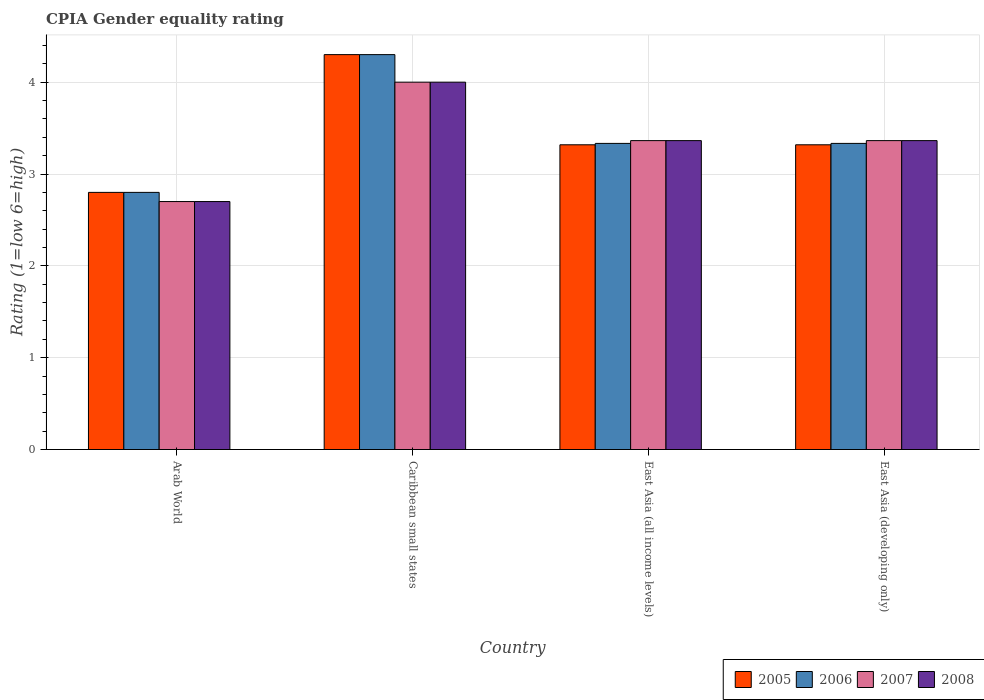How many groups of bars are there?
Offer a terse response. 4. How many bars are there on the 3rd tick from the left?
Your answer should be compact. 4. How many bars are there on the 1st tick from the right?
Your answer should be compact. 4. What is the label of the 1st group of bars from the left?
Provide a succinct answer. Arab World. In how many cases, is the number of bars for a given country not equal to the number of legend labels?
Keep it short and to the point. 0. What is the CPIA rating in 2007 in Caribbean small states?
Keep it short and to the point. 4. Across all countries, what is the minimum CPIA rating in 2007?
Your answer should be compact. 2.7. In which country was the CPIA rating in 2006 maximum?
Your response must be concise. Caribbean small states. In which country was the CPIA rating in 2008 minimum?
Keep it short and to the point. Arab World. What is the total CPIA rating in 2008 in the graph?
Keep it short and to the point. 13.43. What is the difference between the CPIA rating in 2006 in East Asia (all income levels) and the CPIA rating in 2005 in East Asia (developing only)?
Your response must be concise. 0.02. What is the average CPIA rating in 2007 per country?
Your answer should be compact. 3.36. What is the difference between the CPIA rating of/in 2008 and CPIA rating of/in 2007 in East Asia (all income levels)?
Your answer should be compact. 0. What is the ratio of the CPIA rating in 2008 in Caribbean small states to that in East Asia (all income levels)?
Your response must be concise. 1.19. What is the difference between the highest and the second highest CPIA rating in 2008?
Provide a succinct answer. -0.64. What is the difference between the highest and the lowest CPIA rating in 2006?
Give a very brief answer. 1.5. What does the 1st bar from the right in Caribbean small states represents?
Your response must be concise. 2008. Is it the case that in every country, the sum of the CPIA rating in 2006 and CPIA rating in 2005 is greater than the CPIA rating in 2008?
Make the answer very short. Yes. How many bars are there?
Make the answer very short. 16. How many countries are there in the graph?
Provide a short and direct response. 4. What is the difference between two consecutive major ticks on the Y-axis?
Provide a short and direct response. 1. Are the values on the major ticks of Y-axis written in scientific E-notation?
Your response must be concise. No. Does the graph contain any zero values?
Offer a terse response. No. What is the title of the graph?
Offer a terse response. CPIA Gender equality rating. What is the label or title of the X-axis?
Ensure brevity in your answer.  Country. What is the label or title of the Y-axis?
Keep it short and to the point. Rating (1=low 6=high). What is the Rating (1=low 6=high) in 2006 in Caribbean small states?
Offer a very short reply. 4.3. What is the Rating (1=low 6=high) in 2007 in Caribbean small states?
Provide a short and direct response. 4. What is the Rating (1=low 6=high) in 2008 in Caribbean small states?
Keep it short and to the point. 4. What is the Rating (1=low 6=high) of 2005 in East Asia (all income levels)?
Offer a terse response. 3.32. What is the Rating (1=low 6=high) of 2006 in East Asia (all income levels)?
Provide a succinct answer. 3.33. What is the Rating (1=low 6=high) in 2007 in East Asia (all income levels)?
Give a very brief answer. 3.36. What is the Rating (1=low 6=high) in 2008 in East Asia (all income levels)?
Your answer should be very brief. 3.36. What is the Rating (1=low 6=high) of 2005 in East Asia (developing only)?
Your answer should be very brief. 3.32. What is the Rating (1=low 6=high) of 2006 in East Asia (developing only)?
Provide a short and direct response. 3.33. What is the Rating (1=low 6=high) of 2007 in East Asia (developing only)?
Give a very brief answer. 3.36. What is the Rating (1=low 6=high) of 2008 in East Asia (developing only)?
Your answer should be compact. 3.36. Across all countries, what is the maximum Rating (1=low 6=high) in 2005?
Provide a succinct answer. 4.3. Across all countries, what is the maximum Rating (1=low 6=high) of 2006?
Provide a short and direct response. 4.3. Across all countries, what is the minimum Rating (1=low 6=high) in 2006?
Offer a very short reply. 2.8. Across all countries, what is the minimum Rating (1=low 6=high) in 2007?
Keep it short and to the point. 2.7. Across all countries, what is the minimum Rating (1=low 6=high) in 2008?
Your answer should be compact. 2.7. What is the total Rating (1=low 6=high) in 2005 in the graph?
Offer a terse response. 13.74. What is the total Rating (1=low 6=high) of 2006 in the graph?
Provide a succinct answer. 13.77. What is the total Rating (1=low 6=high) of 2007 in the graph?
Provide a short and direct response. 13.43. What is the total Rating (1=low 6=high) of 2008 in the graph?
Your response must be concise. 13.43. What is the difference between the Rating (1=low 6=high) of 2005 in Arab World and that in Caribbean small states?
Offer a very short reply. -1.5. What is the difference between the Rating (1=low 6=high) in 2006 in Arab World and that in Caribbean small states?
Make the answer very short. -1.5. What is the difference between the Rating (1=low 6=high) of 2007 in Arab World and that in Caribbean small states?
Your response must be concise. -1.3. What is the difference between the Rating (1=low 6=high) in 2005 in Arab World and that in East Asia (all income levels)?
Your answer should be compact. -0.52. What is the difference between the Rating (1=low 6=high) in 2006 in Arab World and that in East Asia (all income levels)?
Offer a very short reply. -0.53. What is the difference between the Rating (1=low 6=high) of 2007 in Arab World and that in East Asia (all income levels)?
Your response must be concise. -0.66. What is the difference between the Rating (1=low 6=high) in 2008 in Arab World and that in East Asia (all income levels)?
Give a very brief answer. -0.66. What is the difference between the Rating (1=low 6=high) in 2005 in Arab World and that in East Asia (developing only)?
Ensure brevity in your answer.  -0.52. What is the difference between the Rating (1=low 6=high) of 2006 in Arab World and that in East Asia (developing only)?
Offer a terse response. -0.53. What is the difference between the Rating (1=low 6=high) of 2007 in Arab World and that in East Asia (developing only)?
Give a very brief answer. -0.66. What is the difference between the Rating (1=low 6=high) of 2008 in Arab World and that in East Asia (developing only)?
Give a very brief answer. -0.66. What is the difference between the Rating (1=low 6=high) of 2005 in Caribbean small states and that in East Asia (all income levels)?
Offer a very short reply. 0.98. What is the difference between the Rating (1=low 6=high) of 2006 in Caribbean small states and that in East Asia (all income levels)?
Your response must be concise. 0.97. What is the difference between the Rating (1=low 6=high) of 2007 in Caribbean small states and that in East Asia (all income levels)?
Give a very brief answer. 0.64. What is the difference between the Rating (1=low 6=high) in 2008 in Caribbean small states and that in East Asia (all income levels)?
Make the answer very short. 0.64. What is the difference between the Rating (1=low 6=high) of 2005 in Caribbean small states and that in East Asia (developing only)?
Provide a short and direct response. 0.98. What is the difference between the Rating (1=low 6=high) of 2006 in Caribbean small states and that in East Asia (developing only)?
Give a very brief answer. 0.97. What is the difference between the Rating (1=low 6=high) in 2007 in Caribbean small states and that in East Asia (developing only)?
Offer a very short reply. 0.64. What is the difference between the Rating (1=low 6=high) in 2008 in Caribbean small states and that in East Asia (developing only)?
Make the answer very short. 0.64. What is the difference between the Rating (1=low 6=high) of 2006 in East Asia (all income levels) and that in East Asia (developing only)?
Keep it short and to the point. 0. What is the difference between the Rating (1=low 6=high) of 2005 in Arab World and the Rating (1=low 6=high) of 2007 in Caribbean small states?
Offer a terse response. -1.2. What is the difference between the Rating (1=low 6=high) in 2005 in Arab World and the Rating (1=low 6=high) in 2008 in Caribbean small states?
Offer a terse response. -1.2. What is the difference between the Rating (1=low 6=high) of 2005 in Arab World and the Rating (1=low 6=high) of 2006 in East Asia (all income levels)?
Ensure brevity in your answer.  -0.53. What is the difference between the Rating (1=low 6=high) of 2005 in Arab World and the Rating (1=low 6=high) of 2007 in East Asia (all income levels)?
Keep it short and to the point. -0.56. What is the difference between the Rating (1=low 6=high) of 2005 in Arab World and the Rating (1=low 6=high) of 2008 in East Asia (all income levels)?
Your answer should be very brief. -0.56. What is the difference between the Rating (1=low 6=high) in 2006 in Arab World and the Rating (1=low 6=high) in 2007 in East Asia (all income levels)?
Your answer should be very brief. -0.56. What is the difference between the Rating (1=low 6=high) in 2006 in Arab World and the Rating (1=low 6=high) in 2008 in East Asia (all income levels)?
Your answer should be compact. -0.56. What is the difference between the Rating (1=low 6=high) of 2007 in Arab World and the Rating (1=low 6=high) of 2008 in East Asia (all income levels)?
Your answer should be very brief. -0.66. What is the difference between the Rating (1=low 6=high) in 2005 in Arab World and the Rating (1=low 6=high) in 2006 in East Asia (developing only)?
Give a very brief answer. -0.53. What is the difference between the Rating (1=low 6=high) of 2005 in Arab World and the Rating (1=low 6=high) of 2007 in East Asia (developing only)?
Your response must be concise. -0.56. What is the difference between the Rating (1=low 6=high) in 2005 in Arab World and the Rating (1=low 6=high) in 2008 in East Asia (developing only)?
Your response must be concise. -0.56. What is the difference between the Rating (1=low 6=high) in 2006 in Arab World and the Rating (1=low 6=high) in 2007 in East Asia (developing only)?
Your answer should be compact. -0.56. What is the difference between the Rating (1=low 6=high) of 2006 in Arab World and the Rating (1=low 6=high) of 2008 in East Asia (developing only)?
Your answer should be compact. -0.56. What is the difference between the Rating (1=low 6=high) of 2007 in Arab World and the Rating (1=low 6=high) of 2008 in East Asia (developing only)?
Your response must be concise. -0.66. What is the difference between the Rating (1=low 6=high) of 2005 in Caribbean small states and the Rating (1=low 6=high) of 2006 in East Asia (all income levels)?
Provide a succinct answer. 0.97. What is the difference between the Rating (1=low 6=high) in 2005 in Caribbean small states and the Rating (1=low 6=high) in 2007 in East Asia (all income levels)?
Give a very brief answer. 0.94. What is the difference between the Rating (1=low 6=high) in 2005 in Caribbean small states and the Rating (1=low 6=high) in 2008 in East Asia (all income levels)?
Offer a terse response. 0.94. What is the difference between the Rating (1=low 6=high) of 2006 in Caribbean small states and the Rating (1=low 6=high) of 2007 in East Asia (all income levels)?
Make the answer very short. 0.94. What is the difference between the Rating (1=low 6=high) of 2006 in Caribbean small states and the Rating (1=low 6=high) of 2008 in East Asia (all income levels)?
Offer a terse response. 0.94. What is the difference between the Rating (1=low 6=high) in 2007 in Caribbean small states and the Rating (1=low 6=high) in 2008 in East Asia (all income levels)?
Offer a very short reply. 0.64. What is the difference between the Rating (1=low 6=high) of 2005 in Caribbean small states and the Rating (1=low 6=high) of 2006 in East Asia (developing only)?
Ensure brevity in your answer.  0.97. What is the difference between the Rating (1=low 6=high) in 2005 in Caribbean small states and the Rating (1=low 6=high) in 2007 in East Asia (developing only)?
Your answer should be very brief. 0.94. What is the difference between the Rating (1=low 6=high) in 2005 in Caribbean small states and the Rating (1=low 6=high) in 2008 in East Asia (developing only)?
Your answer should be very brief. 0.94. What is the difference between the Rating (1=low 6=high) in 2006 in Caribbean small states and the Rating (1=low 6=high) in 2007 in East Asia (developing only)?
Keep it short and to the point. 0.94. What is the difference between the Rating (1=low 6=high) in 2006 in Caribbean small states and the Rating (1=low 6=high) in 2008 in East Asia (developing only)?
Your response must be concise. 0.94. What is the difference between the Rating (1=low 6=high) in 2007 in Caribbean small states and the Rating (1=low 6=high) in 2008 in East Asia (developing only)?
Offer a very short reply. 0.64. What is the difference between the Rating (1=low 6=high) in 2005 in East Asia (all income levels) and the Rating (1=low 6=high) in 2006 in East Asia (developing only)?
Provide a succinct answer. -0.02. What is the difference between the Rating (1=low 6=high) in 2005 in East Asia (all income levels) and the Rating (1=low 6=high) in 2007 in East Asia (developing only)?
Offer a very short reply. -0.05. What is the difference between the Rating (1=low 6=high) of 2005 in East Asia (all income levels) and the Rating (1=low 6=high) of 2008 in East Asia (developing only)?
Keep it short and to the point. -0.05. What is the difference between the Rating (1=low 6=high) in 2006 in East Asia (all income levels) and the Rating (1=low 6=high) in 2007 in East Asia (developing only)?
Offer a terse response. -0.03. What is the difference between the Rating (1=low 6=high) of 2006 in East Asia (all income levels) and the Rating (1=low 6=high) of 2008 in East Asia (developing only)?
Offer a very short reply. -0.03. What is the average Rating (1=low 6=high) of 2005 per country?
Keep it short and to the point. 3.43. What is the average Rating (1=low 6=high) in 2006 per country?
Your answer should be compact. 3.44. What is the average Rating (1=low 6=high) of 2007 per country?
Make the answer very short. 3.36. What is the average Rating (1=low 6=high) of 2008 per country?
Ensure brevity in your answer.  3.36. What is the difference between the Rating (1=low 6=high) in 2005 and Rating (1=low 6=high) in 2008 in Arab World?
Your answer should be very brief. 0.1. What is the difference between the Rating (1=low 6=high) in 2005 and Rating (1=low 6=high) in 2006 in Caribbean small states?
Offer a very short reply. 0. What is the difference between the Rating (1=low 6=high) of 2005 and Rating (1=low 6=high) of 2008 in Caribbean small states?
Provide a succinct answer. 0.3. What is the difference between the Rating (1=low 6=high) in 2005 and Rating (1=low 6=high) in 2006 in East Asia (all income levels)?
Provide a succinct answer. -0.02. What is the difference between the Rating (1=low 6=high) of 2005 and Rating (1=low 6=high) of 2007 in East Asia (all income levels)?
Give a very brief answer. -0.05. What is the difference between the Rating (1=low 6=high) of 2005 and Rating (1=low 6=high) of 2008 in East Asia (all income levels)?
Keep it short and to the point. -0.05. What is the difference between the Rating (1=low 6=high) in 2006 and Rating (1=low 6=high) in 2007 in East Asia (all income levels)?
Your answer should be compact. -0.03. What is the difference between the Rating (1=low 6=high) in 2006 and Rating (1=low 6=high) in 2008 in East Asia (all income levels)?
Provide a succinct answer. -0.03. What is the difference between the Rating (1=low 6=high) of 2005 and Rating (1=low 6=high) of 2006 in East Asia (developing only)?
Keep it short and to the point. -0.02. What is the difference between the Rating (1=low 6=high) in 2005 and Rating (1=low 6=high) in 2007 in East Asia (developing only)?
Provide a succinct answer. -0.05. What is the difference between the Rating (1=low 6=high) in 2005 and Rating (1=low 6=high) in 2008 in East Asia (developing only)?
Make the answer very short. -0.05. What is the difference between the Rating (1=low 6=high) in 2006 and Rating (1=low 6=high) in 2007 in East Asia (developing only)?
Provide a short and direct response. -0.03. What is the difference between the Rating (1=low 6=high) of 2006 and Rating (1=low 6=high) of 2008 in East Asia (developing only)?
Give a very brief answer. -0.03. What is the difference between the Rating (1=low 6=high) in 2007 and Rating (1=low 6=high) in 2008 in East Asia (developing only)?
Give a very brief answer. 0. What is the ratio of the Rating (1=low 6=high) in 2005 in Arab World to that in Caribbean small states?
Offer a terse response. 0.65. What is the ratio of the Rating (1=low 6=high) of 2006 in Arab World to that in Caribbean small states?
Your answer should be very brief. 0.65. What is the ratio of the Rating (1=low 6=high) of 2007 in Arab World to that in Caribbean small states?
Your response must be concise. 0.68. What is the ratio of the Rating (1=low 6=high) of 2008 in Arab World to that in Caribbean small states?
Keep it short and to the point. 0.68. What is the ratio of the Rating (1=low 6=high) of 2005 in Arab World to that in East Asia (all income levels)?
Provide a succinct answer. 0.84. What is the ratio of the Rating (1=low 6=high) in 2006 in Arab World to that in East Asia (all income levels)?
Give a very brief answer. 0.84. What is the ratio of the Rating (1=low 6=high) in 2007 in Arab World to that in East Asia (all income levels)?
Your answer should be compact. 0.8. What is the ratio of the Rating (1=low 6=high) of 2008 in Arab World to that in East Asia (all income levels)?
Your answer should be very brief. 0.8. What is the ratio of the Rating (1=low 6=high) of 2005 in Arab World to that in East Asia (developing only)?
Offer a very short reply. 0.84. What is the ratio of the Rating (1=low 6=high) in 2006 in Arab World to that in East Asia (developing only)?
Offer a terse response. 0.84. What is the ratio of the Rating (1=low 6=high) of 2007 in Arab World to that in East Asia (developing only)?
Ensure brevity in your answer.  0.8. What is the ratio of the Rating (1=low 6=high) in 2008 in Arab World to that in East Asia (developing only)?
Give a very brief answer. 0.8. What is the ratio of the Rating (1=low 6=high) of 2005 in Caribbean small states to that in East Asia (all income levels)?
Provide a succinct answer. 1.3. What is the ratio of the Rating (1=low 6=high) of 2006 in Caribbean small states to that in East Asia (all income levels)?
Offer a terse response. 1.29. What is the ratio of the Rating (1=low 6=high) of 2007 in Caribbean small states to that in East Asia (all income levels)?
Ensure brevity in your answer.  1.19. What is the ratio of the Rating (1=low 6=high) in 2008 in Caribbean small states to that in East Asia (all income levels)?
Give a very brief answer. 1.19. What is the ratio of the Rating (1=low 6=high) in 2005 in Caribbean small states to that in East Asia (developing only)?
Offer a very short reply. 1.3. What is the ratio of the Rating (1=low 6=high) in 2006 in Caribbean small states to that in East Asia (developing only)?
Provide a short and direct response. 1.29. What is the ratio of the Rating (1=low 6=high) of 2007 in Caribbean small states to that in East Asia (developing only)?
Your response must be concise. 1.19. What is the ratio of the Rating (1=low 6=high) in 2008 in Caribbean small states to that in East Asia (developing only)?
Keep it short and to the point. 1.19. What is the ratio of the Rating (1=low 6=high) of 2005 in East Asia (all income levels) to that in East Asia (developing only)?
Provide a succinct answer. 1. What is the ratio of the Rating (1=low 6=high) of 2006 in East Asia (all income levels) to that in East Asia (developing only)?
Offer a very short reply. 1. What is the ratio of the Rating (1=low 6=high) in 2007 in East Asia (all income levels) to that in East Asia (developing only)?
Offer a terse response. 1. What is the difference between the highest and the second highest Rating (1=low 6=high) of 2005?
Give a very brief answer. 0.98. What is the difference between the highest and the second highest Rating (1=low 6=high) of 2006?
Offer a terse response. 0.97. What is the difference between the highest and the second highest Rating (1=low 6=high) of 2007?
Your response must be concise. 0.64. What is the difference between the highest and the second highest Rating (1=low 6=high) of 2008?
Offer a terse response. 0.64. What is the difference between the highest and the lowest Rating (1=low 6=high) of 2007?
Give a very brief answer. 1.3. What is the difference between the highest and the lowest Rating (1=low 6=high) of 2008?
Offer a terse response. 1.3. 